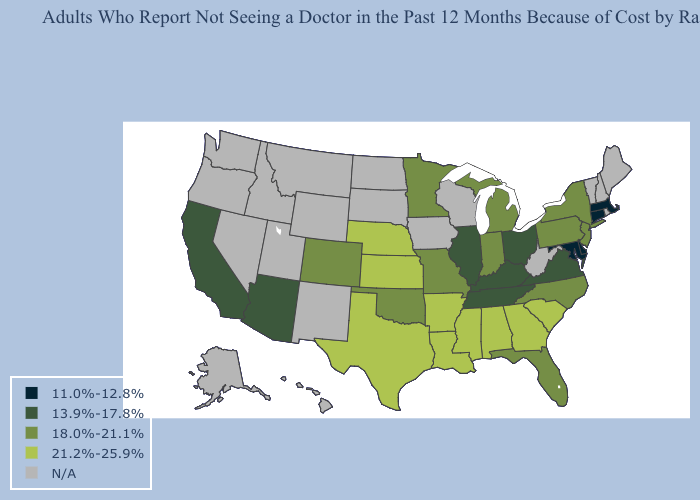What is the value of Mississippi?
Short answer required. 21.2%-25.9%. What is the lowest value in states that border New Mexico?
Quick response, please. 13.9%-17.8%. What is the lowest value in states that border Nebraska?
Be succinct. 18.0%-21.1%. What is the value of South Carolina?
Quick response, please. 21.2%-25.9%. What is the highest value in states that border North Carolina?
Quick response, please. 21.2%-25.9%. Does Connecticut have the lowest value in the Northeast?
Answer briefly. Yes. What is the value of Kentucky?
Write a very short answer. 13.9%-17.8%. Name the states that have a value in the range N/A?
Write a very short answer. Alaska, Hawaii, Idaho, Iowa, Maine, Montana, Nevada, New Hampshire, New Mexico, North Dakota, Oregon, Rhode Island, South Dakota, Utah, Vermont, Washington, West Virginia, Wisconsin, Wyoming. Does Arizona have the lowest value in the USA?
Concise answer only. No. Does Kansas have the highest value in the MidWest?
Be succinct. Yes. Name the states that have a value in the range 21.2%-25.9%?
Concise answer only. Alabama, Arkansas, Georgia, Kansas, Louisiana, Mississippi, Nebraska, South Carolina, Texas. Which states hav the highest value in the MidWest?
Concise answer only. Kansas, Nebraska. What is the value of Idaho?
Write a very short answer. N/A. Which states have the lowest value in the Northeast?
Be succinct. Connecticut, Massachusetts. 